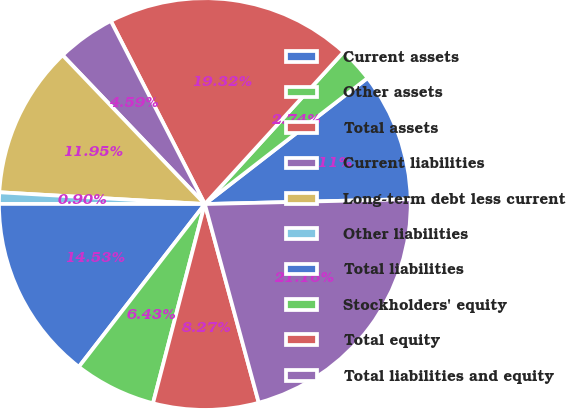Convert chart to OTSL. <chart><loc_0><loc_0><loc_500><loc_500><pie_chart><fcel>Current assets<fcel>Other assets<fcel>Total assets<fcel>Current liabilities<fcel>Long-term debt less current<fcel>Other liabilities<fcel>Total liabilities<fcel>Stockholders' equity<fcel>Total equity<fcel>Total liabilities and equity<nl><fcel>10.11%<fcel>2.74%<fcel>19.32%<fcel>4.59%<fcel>11.95%<fcel>0.9%<fcel>14.53%<fcel>6.43%<fcel>8.27%<fcel>21.16%<nl></chart> 